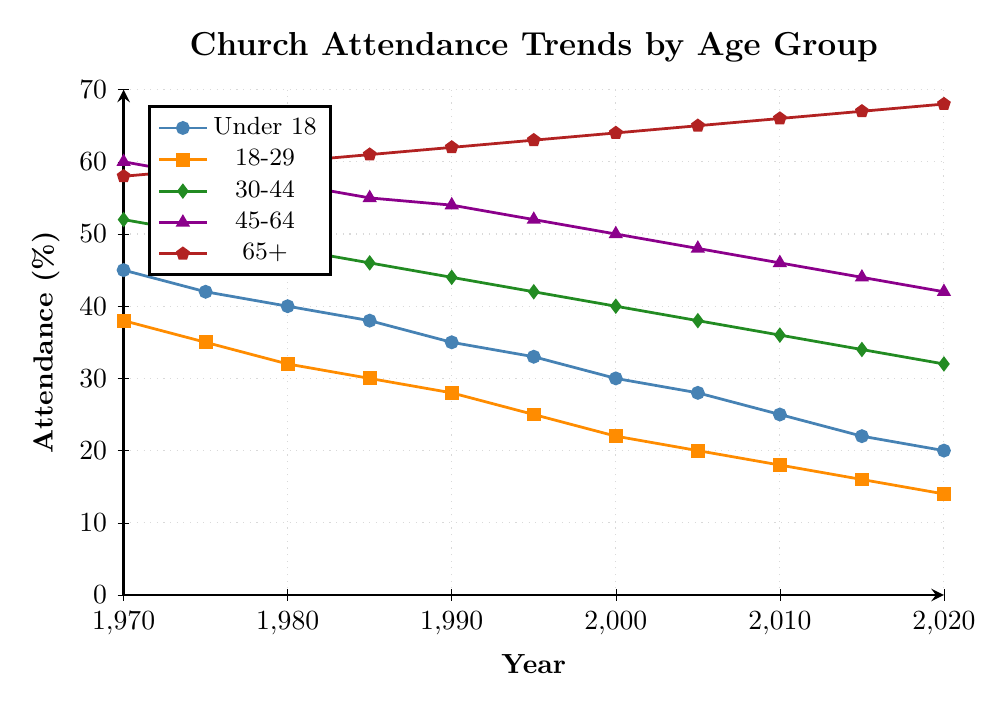Which age group has the highest church attendance in 2020? Looking at the figure, the age group 65+ has the highest church attendance in 2020 with a value of 68%.
Answer: 65+ How many age groups experienced a decrease in church attendance from 1970 to 2020? All five age groups (Under 18, 18-29, 30-44, 45-64, 65+) show a decrease in church attendance over the time period.
Answer: 5 Compare the church attendance of the 30-44 age group and the 65+ age group in 1990. Which one is higher? In 1990, the church attendance for the 30-44 age group is 44%, while for the 65+ age group it is 62%. Therefore, the 65+ age group has higher attendance.
Answer: 65+ What is the overall trend in church attendance for the Under 18 age group from 1970 to 2020? The trend shows a consistent decrease in church attendance from 45% in 1970 to 20% in 2020 for the Under 18 age group.
Answer: Decreasing What is the average church attendance percentage for the 18-29 age group over the 50-year period? Sum of the attendance percentages for 18-29 from 1970 to 2020: 38 + 35 + 32 + 30 + 28 + 25 + 22 + 20 + 18 + 16 + 14 = 278. Number of years/data points: 11. Average = 278 / 11 ≈ 25.27%
Answer: 25.27% Which age group has the least decline in church attendance from 1970 to 2020? Calculating the decline for each age group: 
Under 18: 45% - 20% = 25%
18-29: 38% - 14% = 24%
30-44: 52% - 32% = 20%
45-64: 60% - 42% = 18%
65+: 58% - 68% (increase by 10%)
The age group 65+ actually shows an increase in attendance. Therefore, they have the least (negative) decline.
Answer: 65+ 